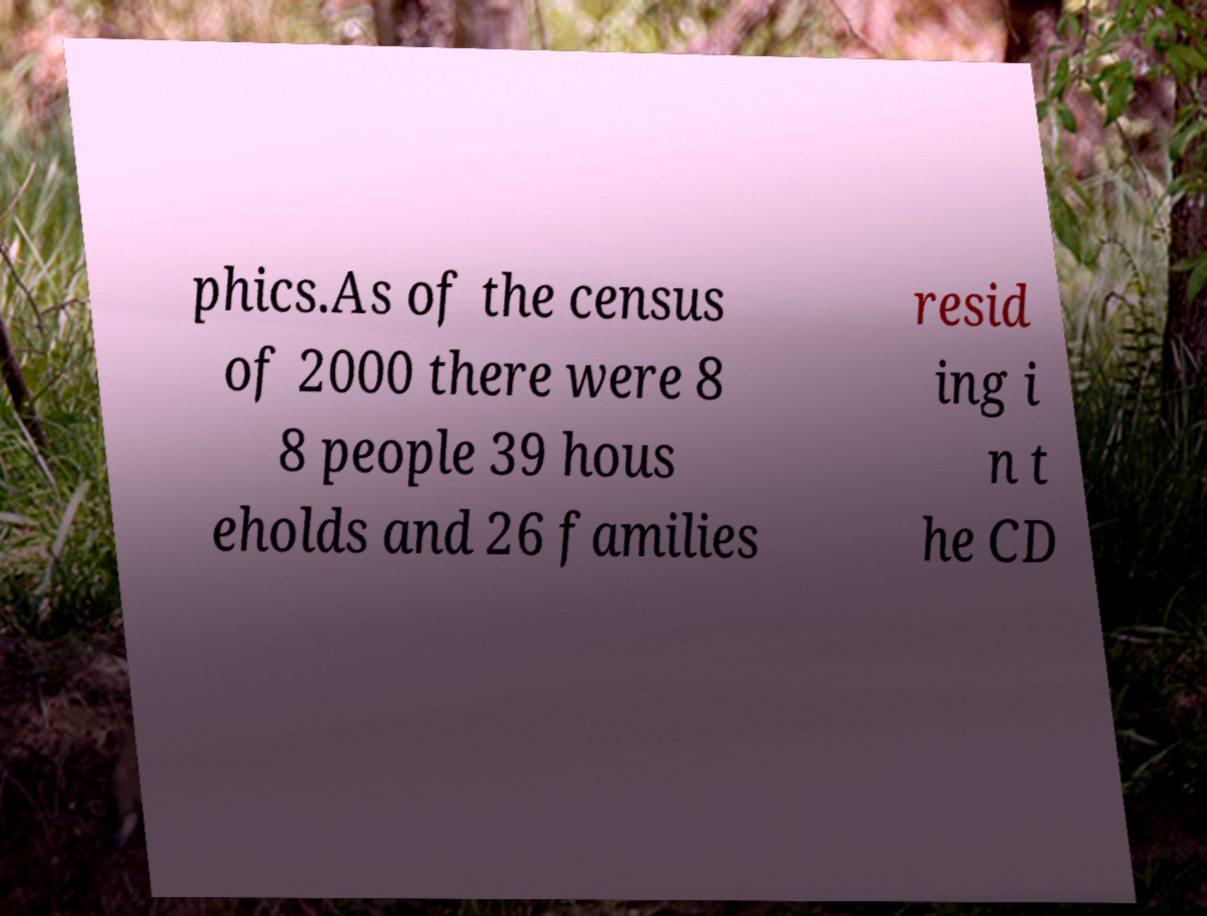Please read and relay the text visible in this image. What does it say? phics.As of the census of 2000 there were 8 8 people 39 hous eholds and 26 families resid ing i n t he CD 